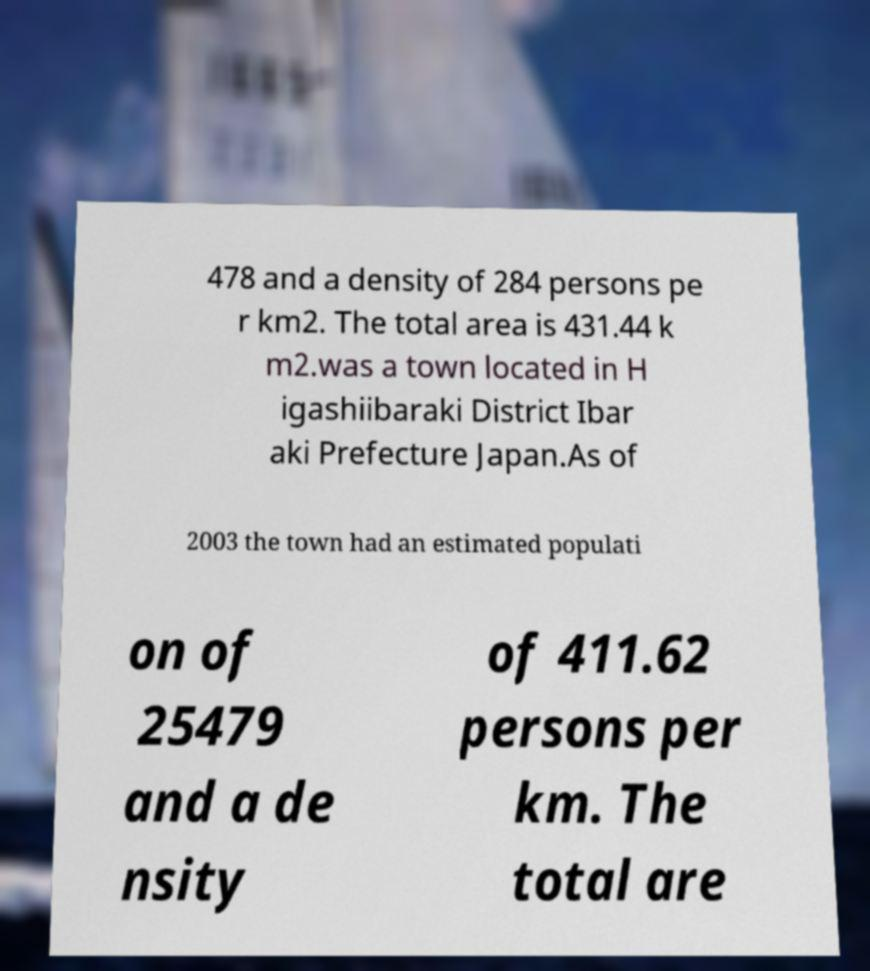Can you read and provide the text displayed in the image?This photo seems to have some interesting text. Can you extract and type it out for me? 478 and a density of 284 persons pe r km2. The total area is 431.44 k m2.was a town located in H igashiibaraki District Ibar aki Prefecture Japan.As of 2003 the town had an estimated populati on of 25479 and a de nsity of 411.62 persons per km. The total are 